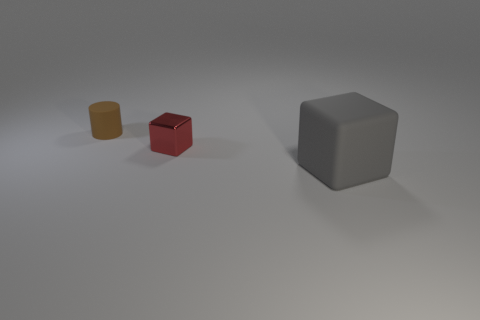Are there fewer red objects than tiny brown metal blocks?
Offer a terse response. No. How many gray matte cubes are to the right of the rubber object that is left of the rubber object in front of the small brown cylinder?
Ensure brevity in your answer.  1. How big is the rubber object on the right side of the small rubber object?
Provide a succinct answer. Large. Does the thing in front of the red metal cube have the same shape as the tiny red metallic thing?
Offer a very short reply. Yes. What is the material of the other object that is the same shape as the small red thing?
Your answer should be very brief. Rubber. Is there anything else that has the same size as the gray object?
Provide a short and direct response. No. Are any large cyan shiny spheres visible?
Offer a very short reply. No. What is the material of the block that is to the right of the small object that is in front of the matte thing that is on the left side of the big matte cube?
Make the answer very short. Rubber. Does the small red thing have the same shape as the gray object in front of the tiny block?
Provide a succinct answer. Yes. What number of other gray rubber things are the same shape as the gray matte thing?
Give a very brief answer. 0. 